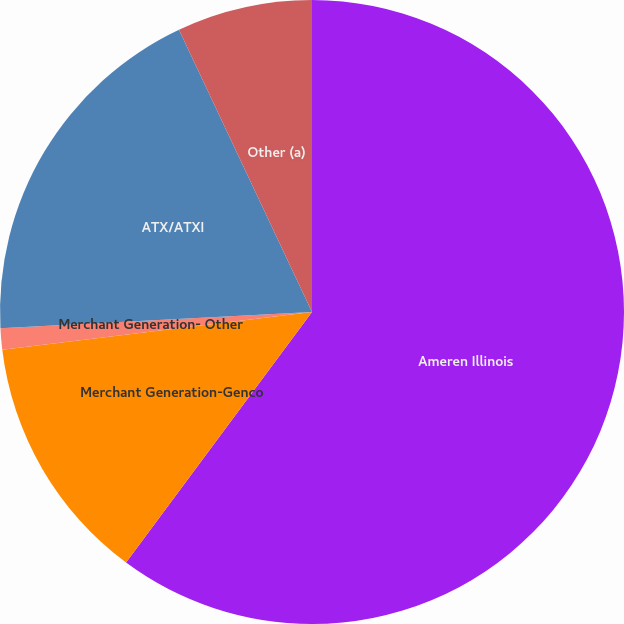Convert chart. <chart><loc_0><loc_0><loc_500><loc_500><pie_chart><fcel>Ameren Illinois<fcel>Merchant Generation-Genco<fcel>Merchant Generation- Other<fcel>ATX/ATXI<fcel>Other (a)<nl><fcel>60.16%<fcel>12.91%<fcel>1.1%<fcel>18.82%<fcel>7.01%<nl></chart> 